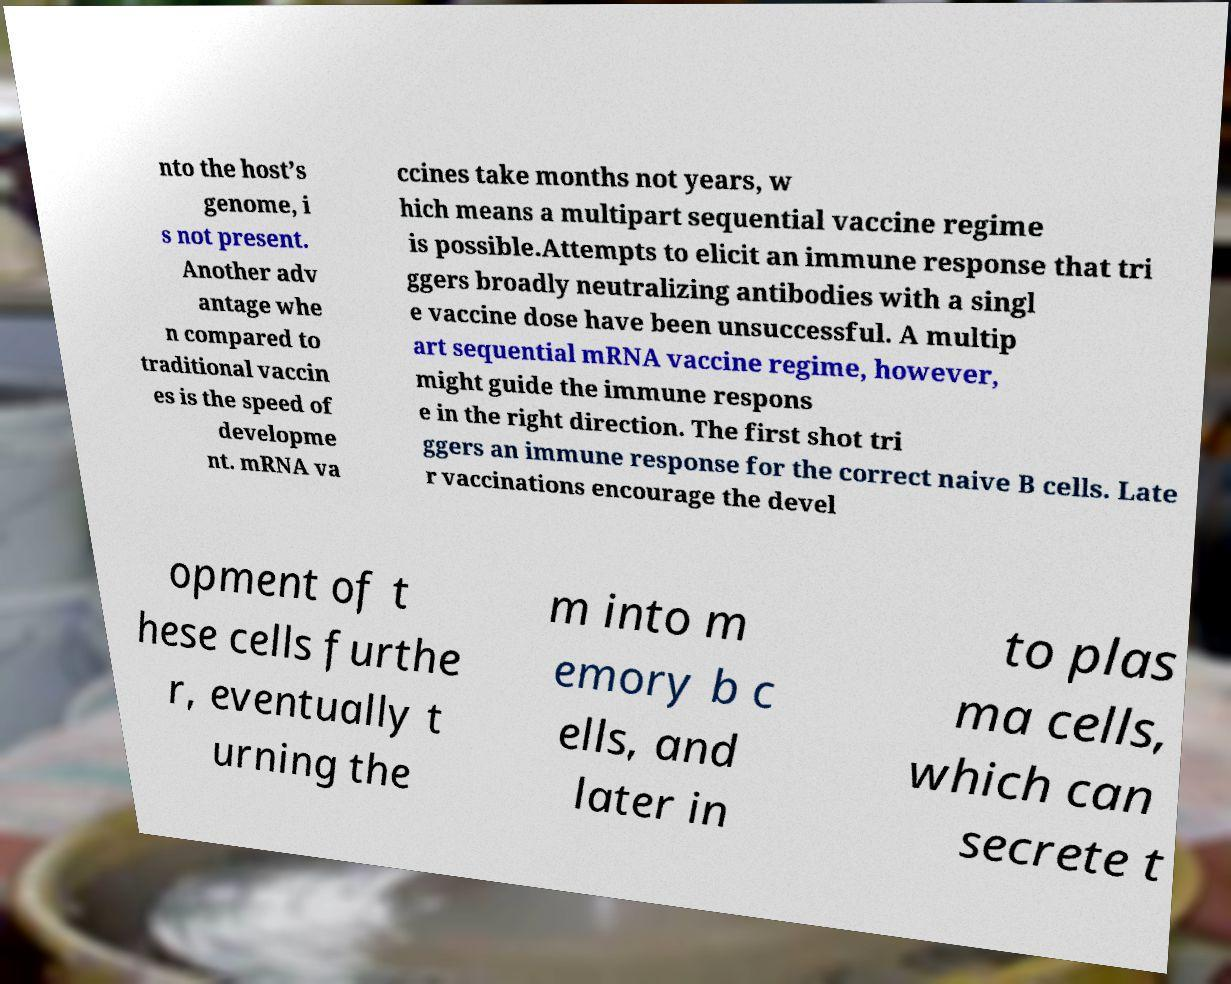Can you read and provide the text displayed in the image?This photo seems to have some interesting text. Can you extract and type it out for me? nto the host’s genome, i s not present. Another adv antage whe n compared to traditional vaccin es is the speed of developme nt. mRNA va ccines take months not years, w hich means a multipart sequential vaccine regime is possible.Attempts to elicit an immune response that tri ggers broadly neutralizing antibodies with a singl e vaccine dose have been unsuccessful. A multip art sequential mRNA vaccine regime, however, might guide the immune respons e in the right direction. The first shot tri ggers an immune response for the correct naive B cells. Late r vaccinations encourage the devel opment of t hese cells furthe r, eventually t urning the m into m emory b c ells, and later in to plas ma cells, which can secrete t 